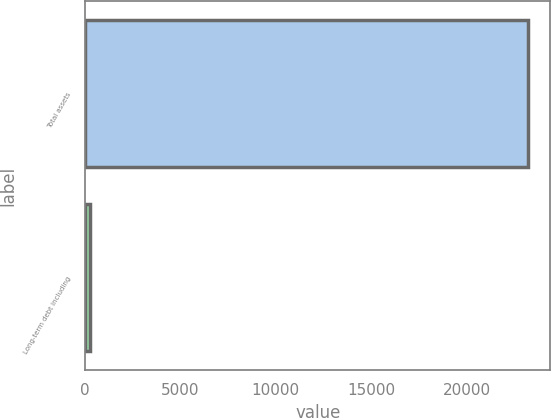Convert chart to OTSL. <chart><loc_0><loc_0><loc_500><loc_500><bar_chart><fcel>Total assets<fcel>Long-term debt including<nl><fcel>23232<fcel>279<nl></chart> 